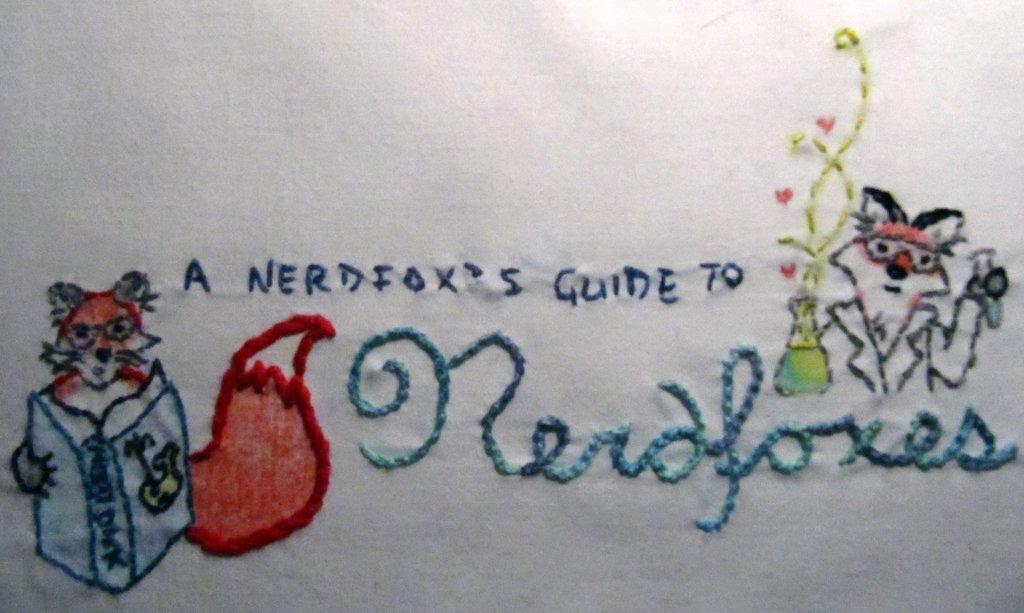In one or two sentences, can you explain what this image depicts? In this image we can see embroidery of text and animals on the cloth. 